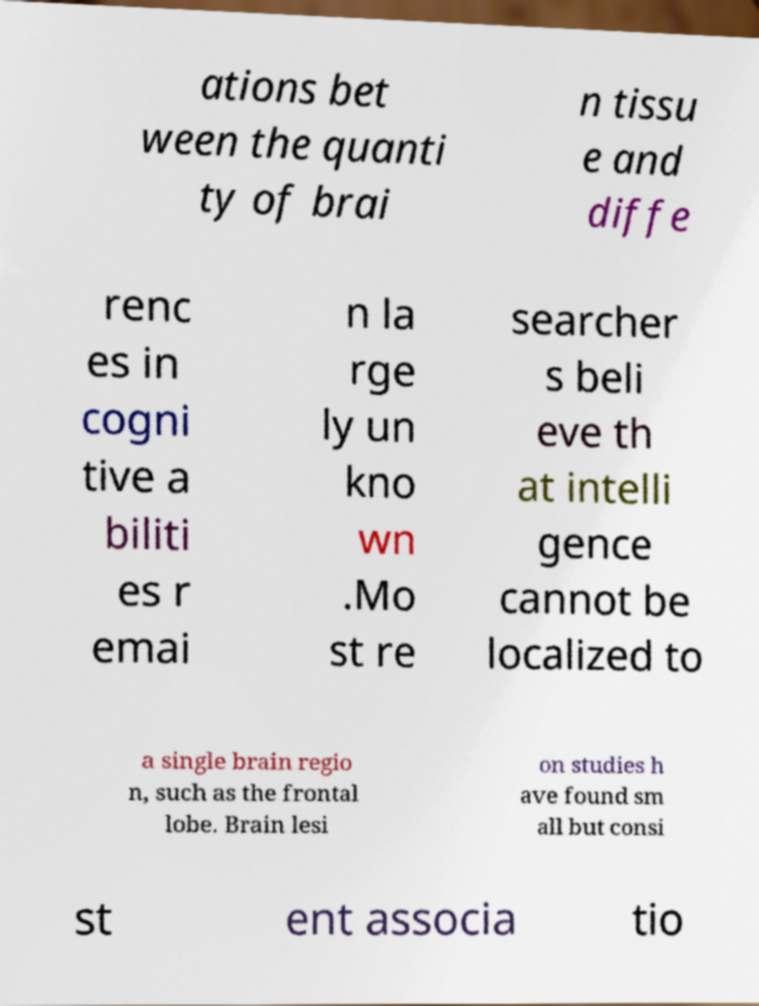Please identify and transcribe the text found in this image. ations bet ween the quanti ty of brai n tissu e and diffe renc es in cogni tive a biliti es r emai n la rge ly un kno wn .Mo st re searcher s beli eve th at intelli gence cannot be localized to a single brain regio n, such as the frontal lobe. Brain lesi on studies h ave found sm all but consi st ent associa tio 